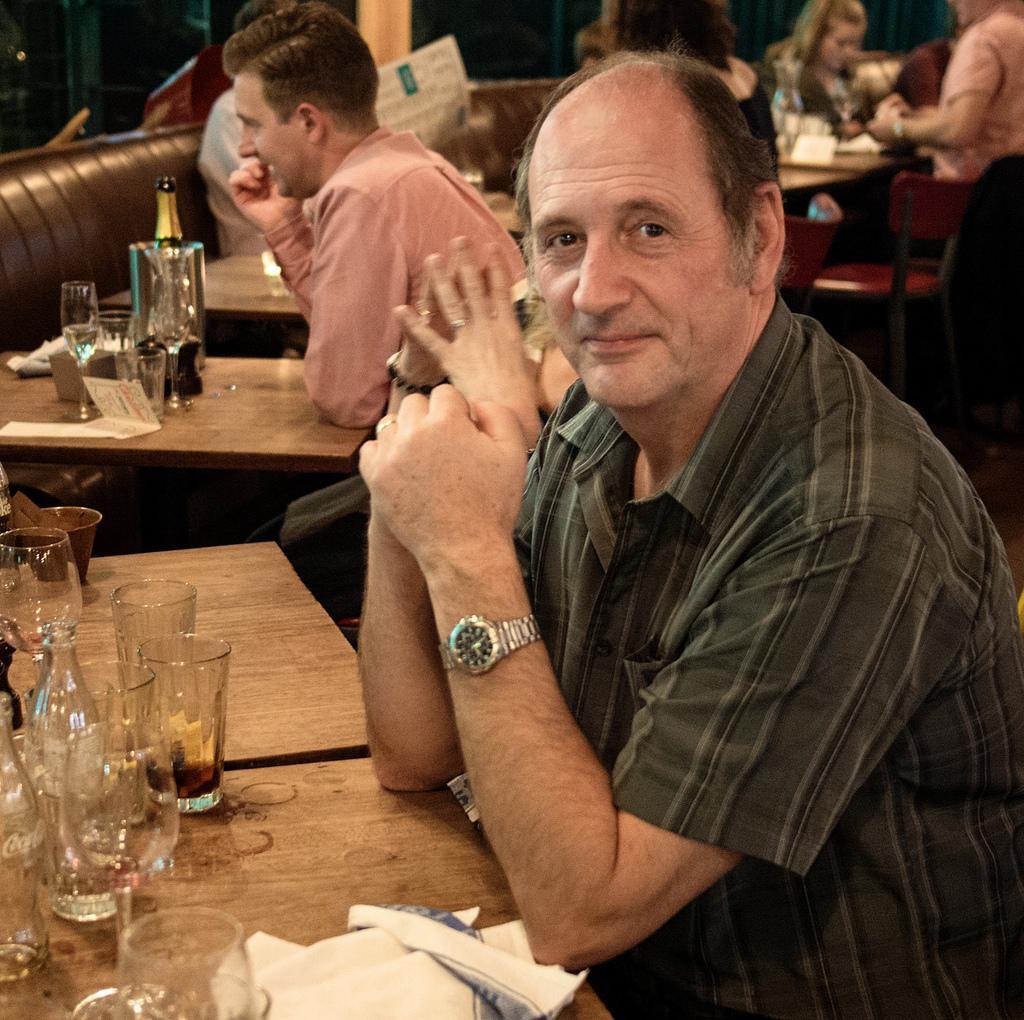Please provide a concise description of this image. In this picture there are people sitting and we can see bottles, glasses and objects on tables. We can see chairs and sofas. 